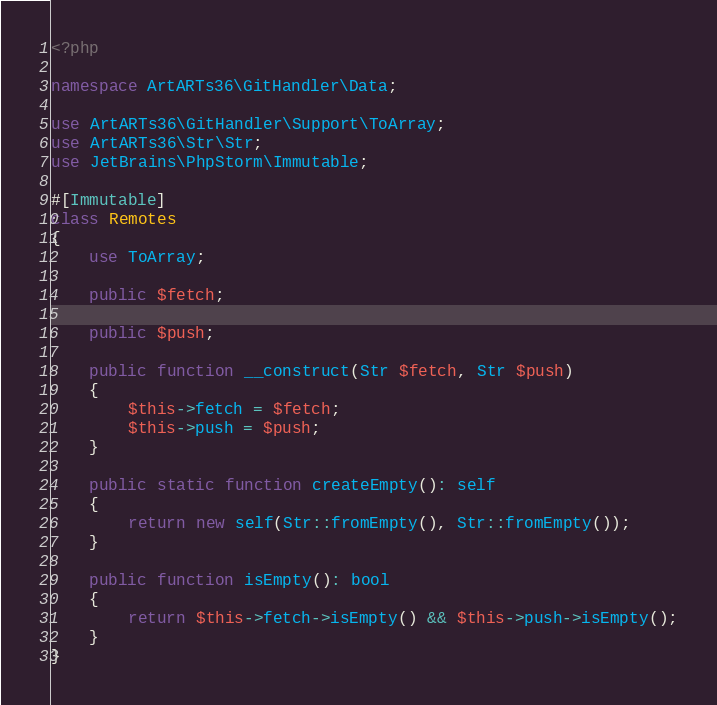<code> <loc_0><loc_0><loc_500><loc_500><_PHP_><?php

namespace ArtARTs36\GitHandler\Data;

use ArtARTs36\GitHandler\Support\ToArray;
use ArtARTs36\Str\Str;
use JetBrains\PhpStorm\Immutable;

#[Immutable]
class Remotes
{
    use ToArray;

    public $fetch;

    public $push;

    public function __construct(Str $fetch, Str $push)
    {
        $this->fetch = $fetch;
        $this->push = $push;
    }

    public static function createEmpty(): self
    {
        return new self(Str::fromEmpty(), Str::fromEmpty());
    }

    public function isEmpty(): bool
    {
        return $this->fetch->isEmpty() && $this->push->isEmpty();
    }
}
</code> 